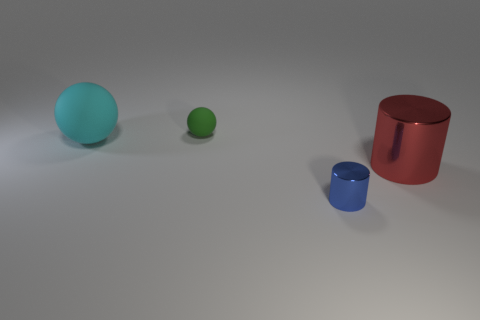What materials do the objects in the image appear to be made of? The objects in the image have a smooth and matte finish, which suggests they could be made of materials like plastic or painted metal, often used for 3D modeling. 